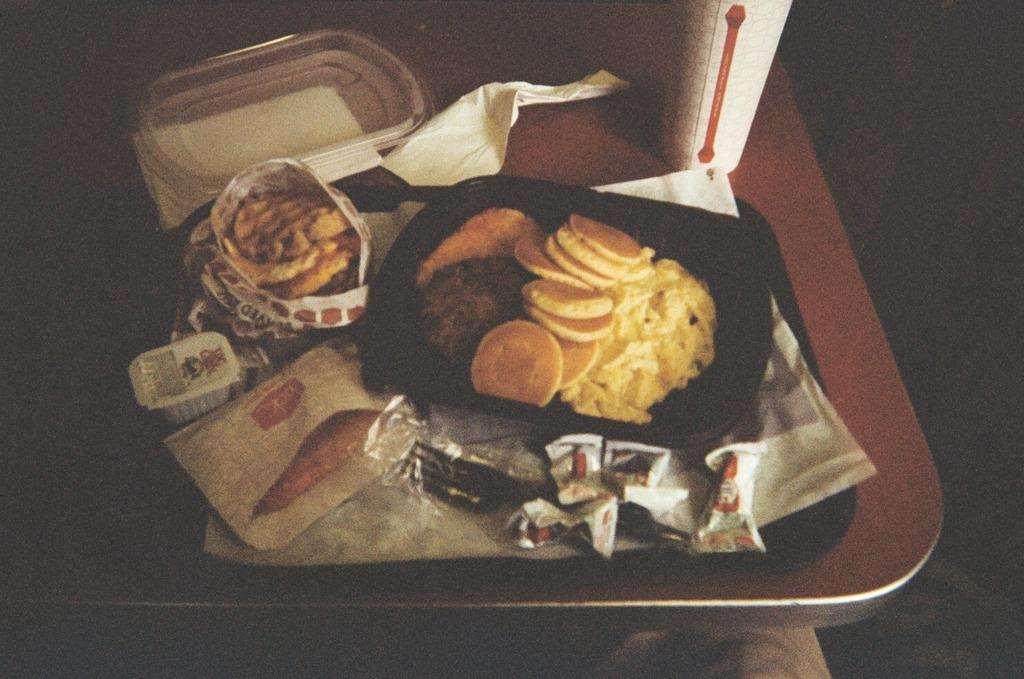What is on the tray in the image? There are food items on a tray in the image. Where is the tray located? The tray is on a table in the image. What else can be seen in the image besides the tray and food items? There is a bottle present in the image. Is there a woman celebrating her birthday in the image? There is no woman or birthday celebration present in the image. 